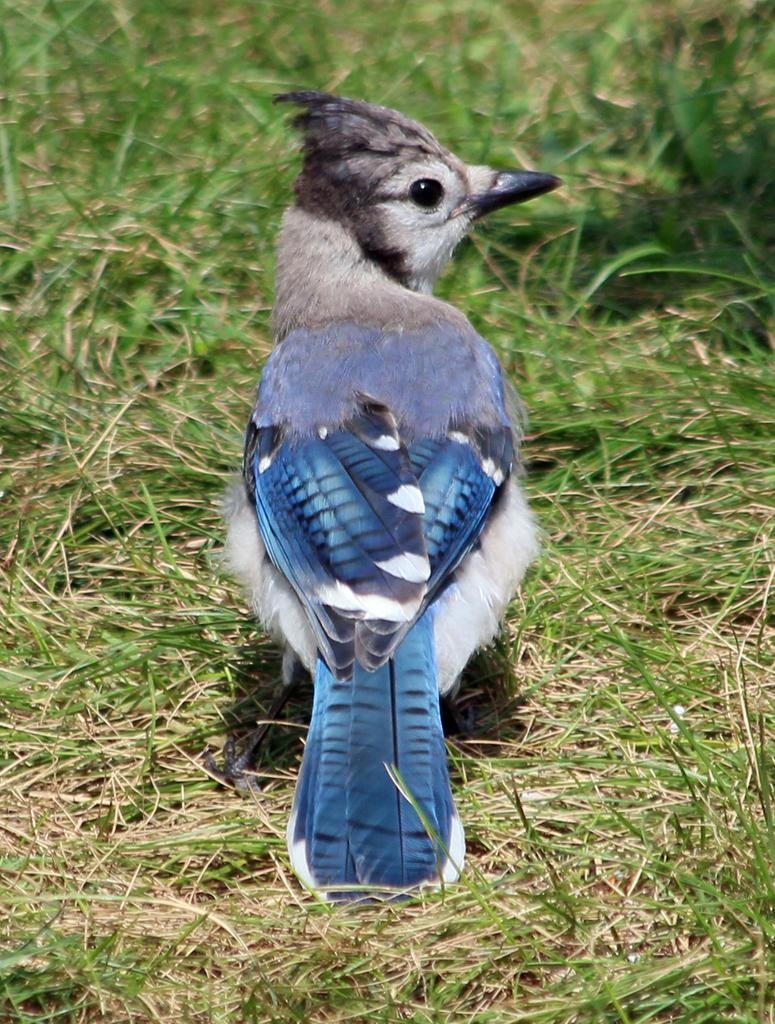What type of animal is on the ground in the image? There is a bird on the ground in the image. What type of vegetation is on the ground in the image? There is grass on the ground in the image. Can you describe the background of the image? The background of the image is blurred. What type of cushion is the bird sitting on in the image? There is no cushion present in the image; the bird is on the ground. 